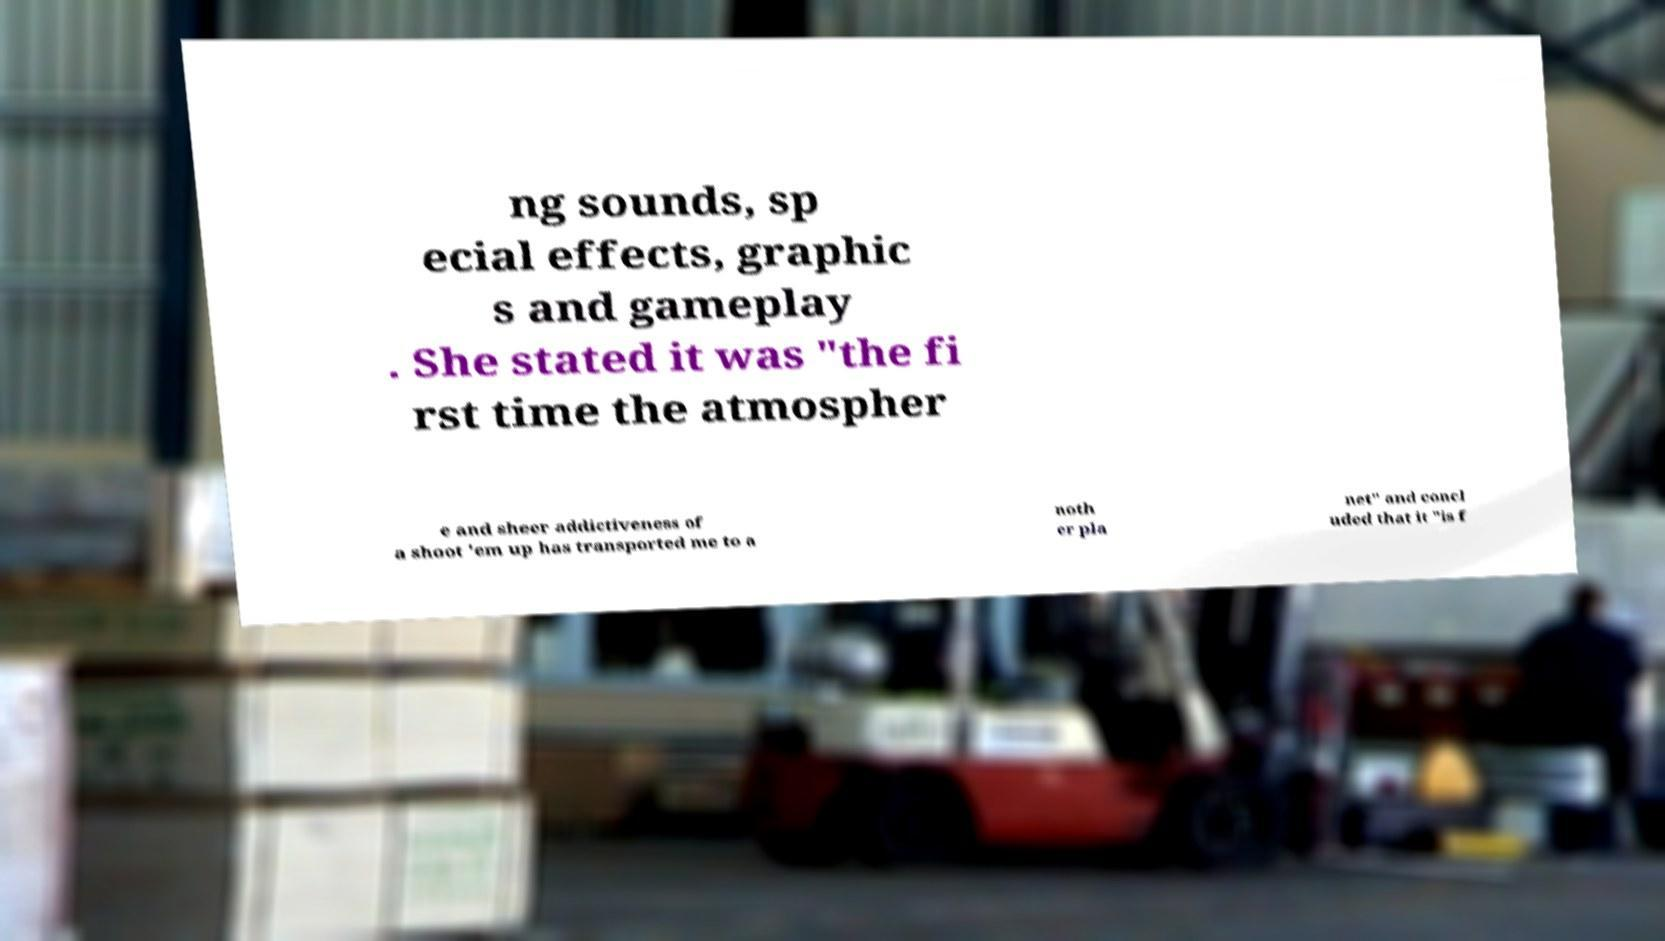For documentation purposes, I need the text within this image transcribed. Could you provide that? ng sounds, sp ecial effects, graphic s and gameplay . She stated it was "the fi rst time the atmospher e and sheer addictiveness of a shoot 'em up has transported me to a noth er pla net" and concl uded that it "is f 